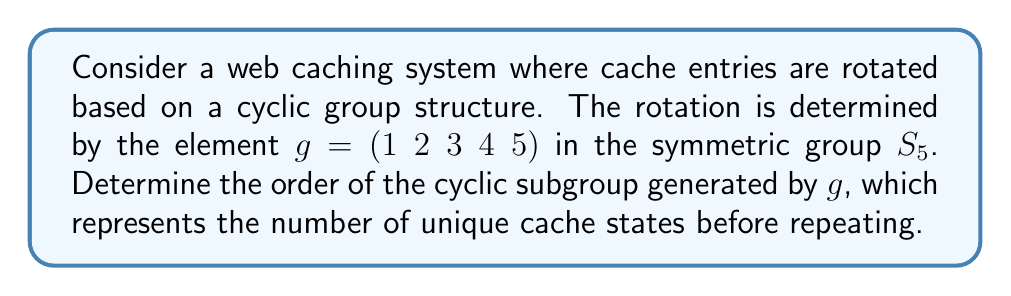What is the answer to this math problem? To determine the order of the cyclic subgroup generated by $g = (1\;2\;3\;4\;5)$, we need to find the smallest positive integer $n$ such that $g^n = e$, where $e$ is the identity element.

Let's examine the powers of $g$:

$g^1 = (1\;2\;3\;4\;5)$
$g^2 = (1\;3\;5\;2\;4)$
$g^3 = (1\;4\;2\;5\;3)$
$g^4 = (1\;5\;4\;3\;2)$
$g^5 = (1)(2)(3)(4)(5) = e$

We can see that $g^5 = e$, which means that after 5 applications of the permutation, we return to the identity (i.e., the original cache state).

Therefore, the order of the cyclic subgroup generated by $g$ is 5.

In terms of caching, this means that the cache will go through 5 unique states before returning to its original configuration. This could be useful for implementing a round-robin caching strategy with 5 distinct cache positions.
Answer: The order of the cyclic subgroup generated by $g = (1\;2\;3\;4\;5)$ is 5. 